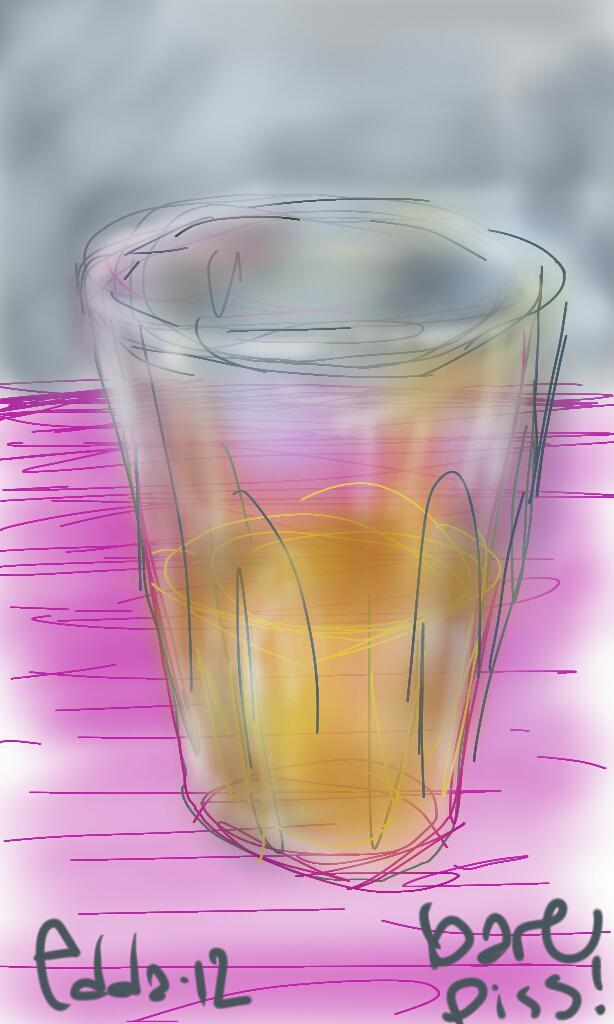What type of artwork is depicted in the image? The image is a painting. What object can be seen in the painting? There is a glass in the painting. How many pets are visible in the painting? There are no pets visible in the painting; it only features a glass. 